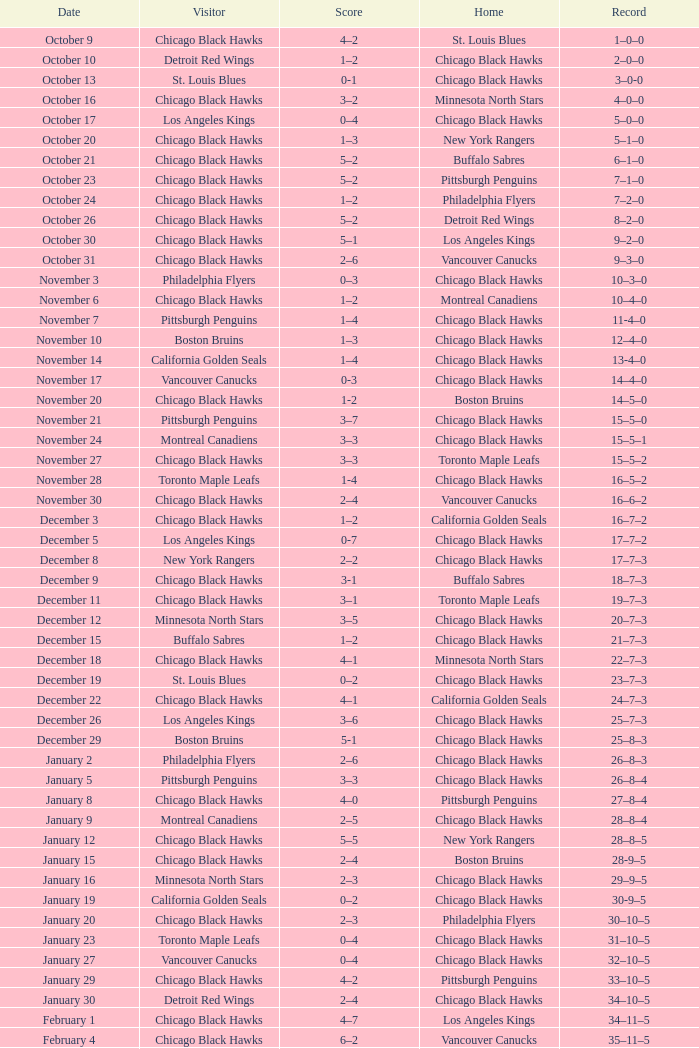What is the account from february 10? 36–13–5. 